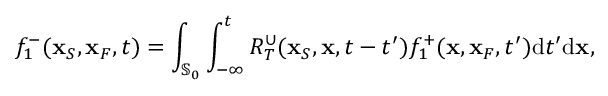<formula> <loc_0><loc_0><loc_500><loc_500>f _ { 1 } ^ { - } ( { x } _ { S } , { x } _ { F } , t ) = \int _ { { \mathbb { S } _ { 0 } } } \int _ { - \infty } ^ { t } R _ { T } ^ { \cup } ( { x } _ { S } , { x } , t - t ^ { \prime } ) f _ { 1 } ^ { + } ( { x } , { x } _ { F } , t ^ { \prime } ) d t ^ { \prime } d { x } ,</formula> 